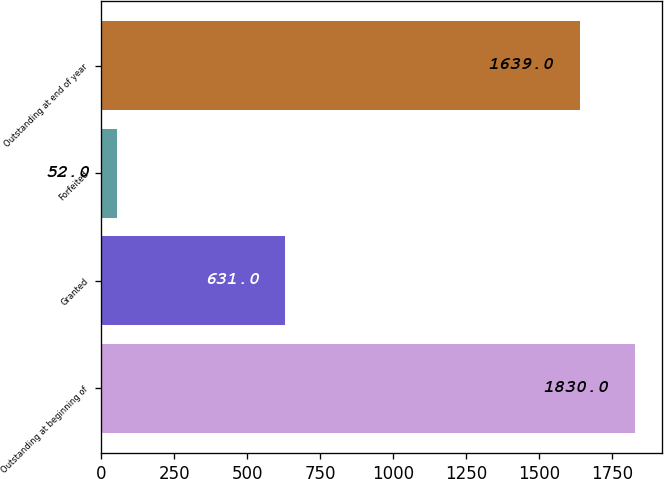<chart> <loc_0><loc_0><loc_500><loc_500><bar_chart><fcel>Outstanding at beginning of<fcel>Granted<fcel>Forfeited<fcel>Outstanding at end of year<nl><fcel>1830<fcel>631<fcel>52<fcel>1639<nl></chart> 